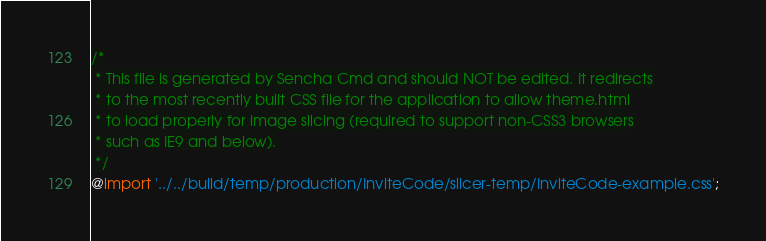Convert code to text. <code><loc_0><loc_0><loc_500><loc_500><_CSS_>

/*
 * This file is generated by Sencha Cmd and should NOT be edited. It redirects
 * to the most recently built CSS file for the application to allow theme.html
 * to load properly for image slicing (required to support non-CSS3 browsers
 * such as IE9 and below).
 */
@import '../../build/temp/production/InviteCode/slicer-temp/InviteCode-example.css';

</code> 